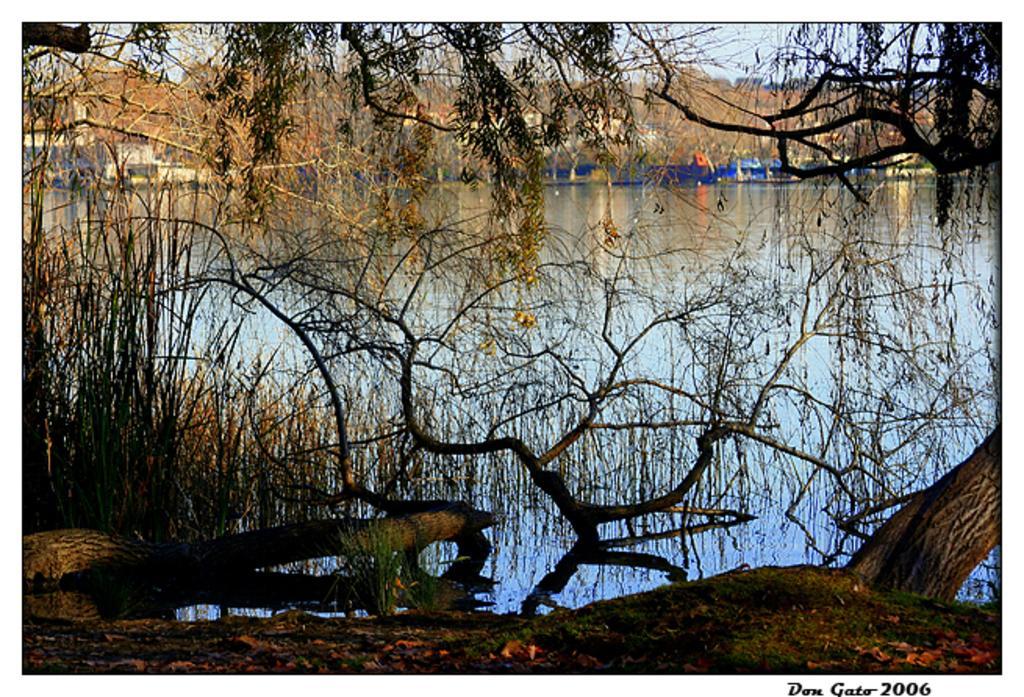Please provide a concise description of this image. In the foreground of the image we can see a group of trees. In the center of the image we can see a lake with water. In the background, we can see a building and the sky. At the bottom we can see some text. 